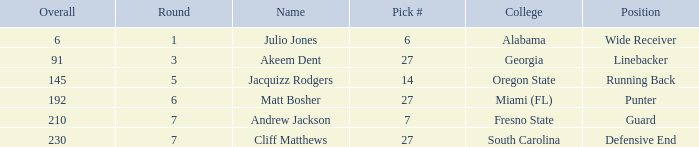Which overall's pick number was 14? 145.0. 